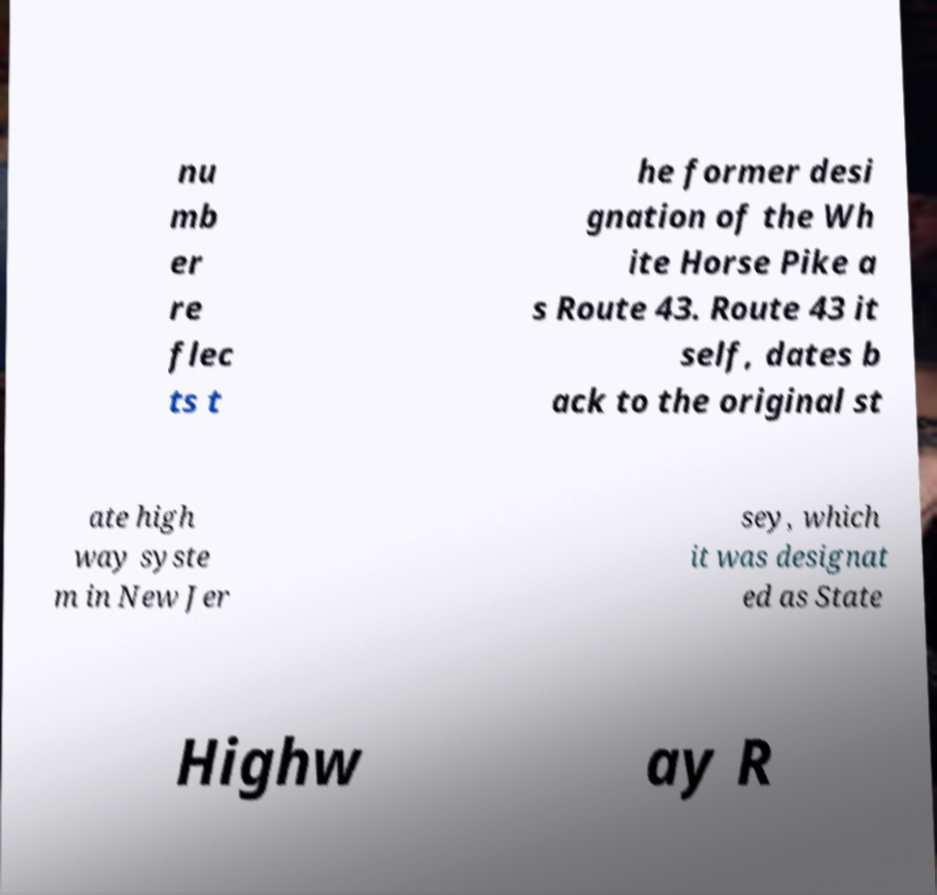Could you extract and type out the text from this image? nu mb er re flec ts t he former desi gnation of the Wh ite Horse Pike a s Route 43. Route 43 it self, dates b ack to the original st ate high way syste m in New Jer sey, which it was designat ed as State Highw ay R 